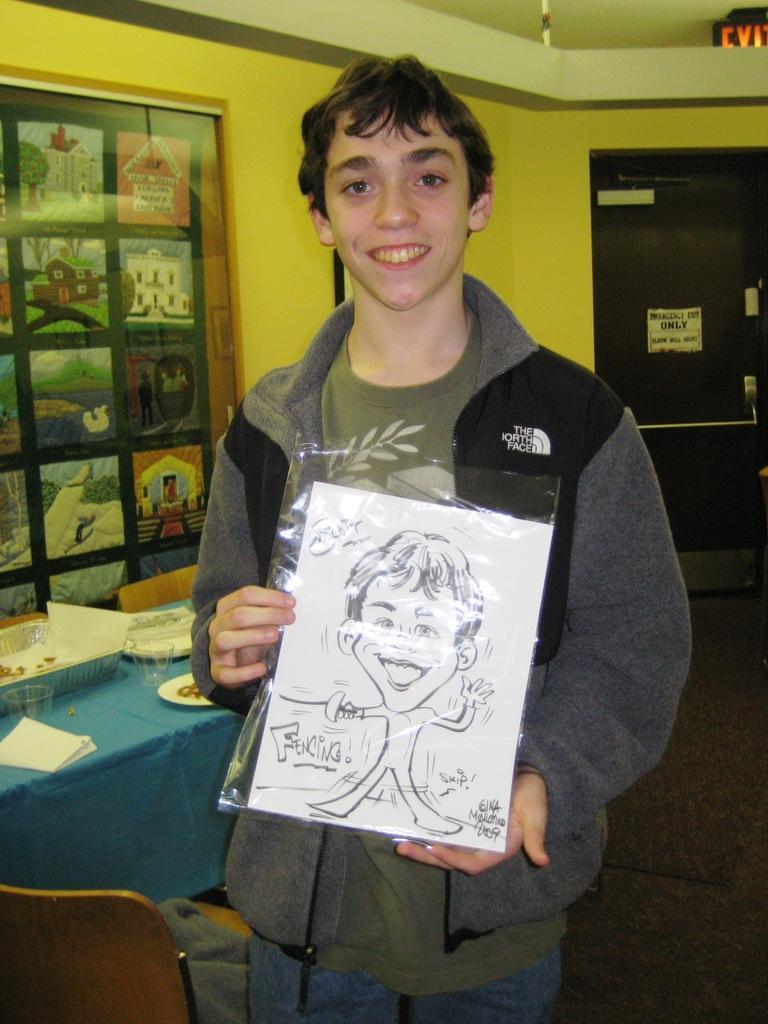Describe this image in one or two sentences. In this picture we can see a man, he is smiling and he is holding a paper, in the background we can find few glasses, basket and plates on the table. 